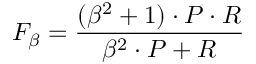Convert formula to latex. <formula><loc_0><loc_0><loc_500><loc_500>F _ { \beta } = { \frac { ( \beta ^ { 2 } + 1 ) \cdot P \cdot R } { \beta ^ { 2 } \cdot P + R } }</formula> 